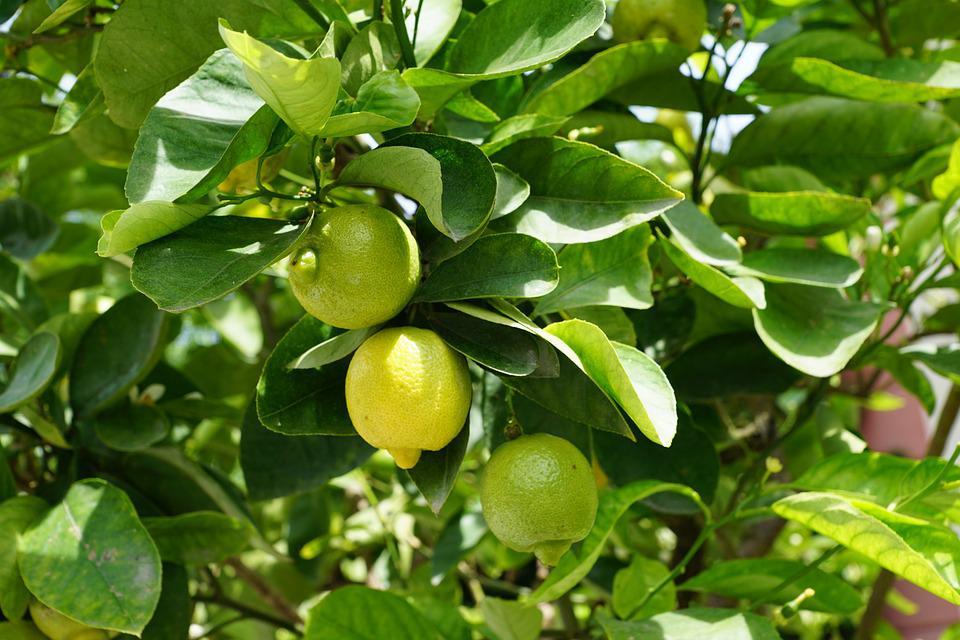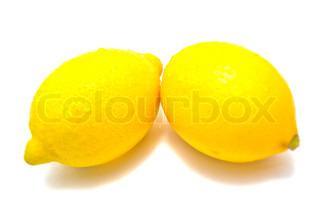The first image is the image on the left, the second image is the image on the right. For the images shown, is this caption "One image contains only two whole lemons with peels intact." true? Answer yes or no. Yes. The first image is the image on the left, the second image is the image on the right. Examine the images to the left and right. Is the description "The right image contains no more than three lemons." accurate? Answer yes or no. Yes. 